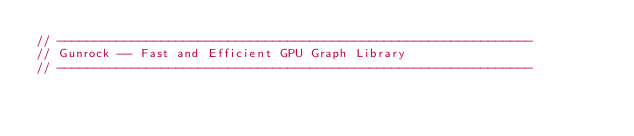<code> <loc_0><loc_0><loc_500><loc_500><_Cuda_>// ----------------------------------------------------------------
// Gunrock -- Fast and Efficient GPU Graph Library
// ----------------------------------------------------------------</code> 